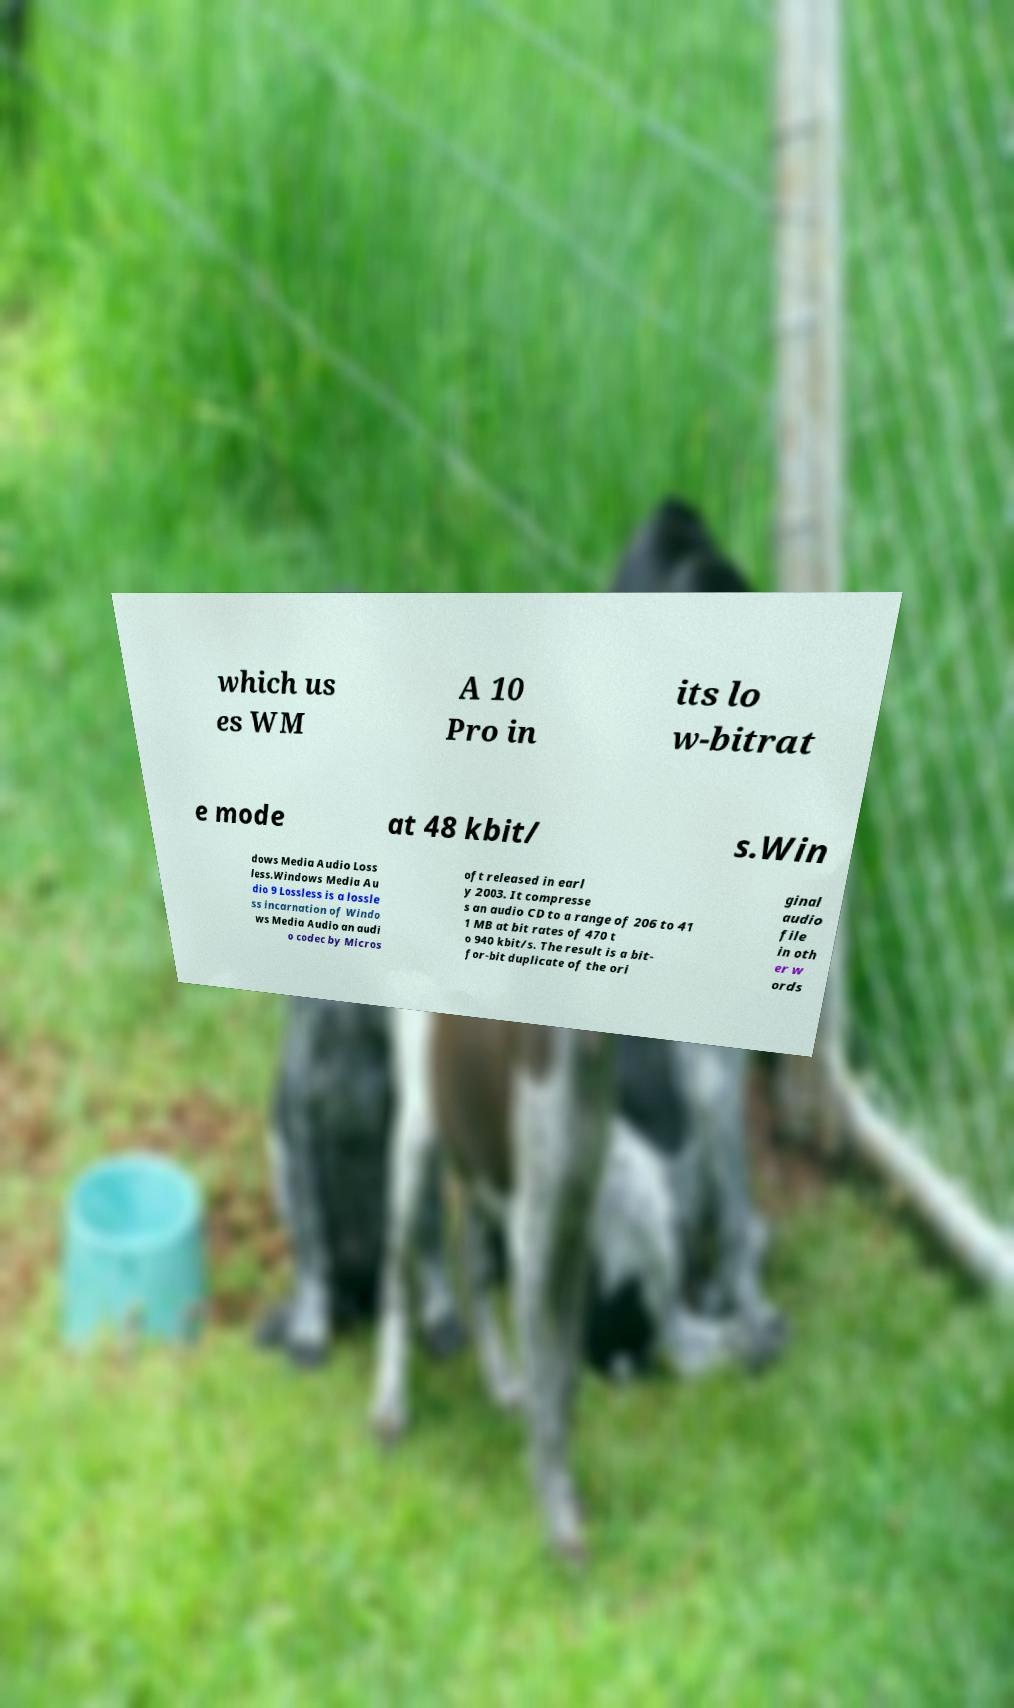For documentation purposes, I need the text within this image transcribed. Could you provide that? which us es WM A 10 Pro in its lo w-bitrat e mode at 48 kbit/ s.Win dows Media Audio Loss less.Windows Media Au dio 9 Lossless is a lossle ss incarnation of Windo ws Media Audio an audi o codec by Micros oft released in earl y 2003. It compresse s an audio CD to a range of 206 to 41 1 MB at bit rates of 470 t o 940 kbit/s. The result is a bit- for-bit duplicate of the ori ginal audio file in oth er w ords 